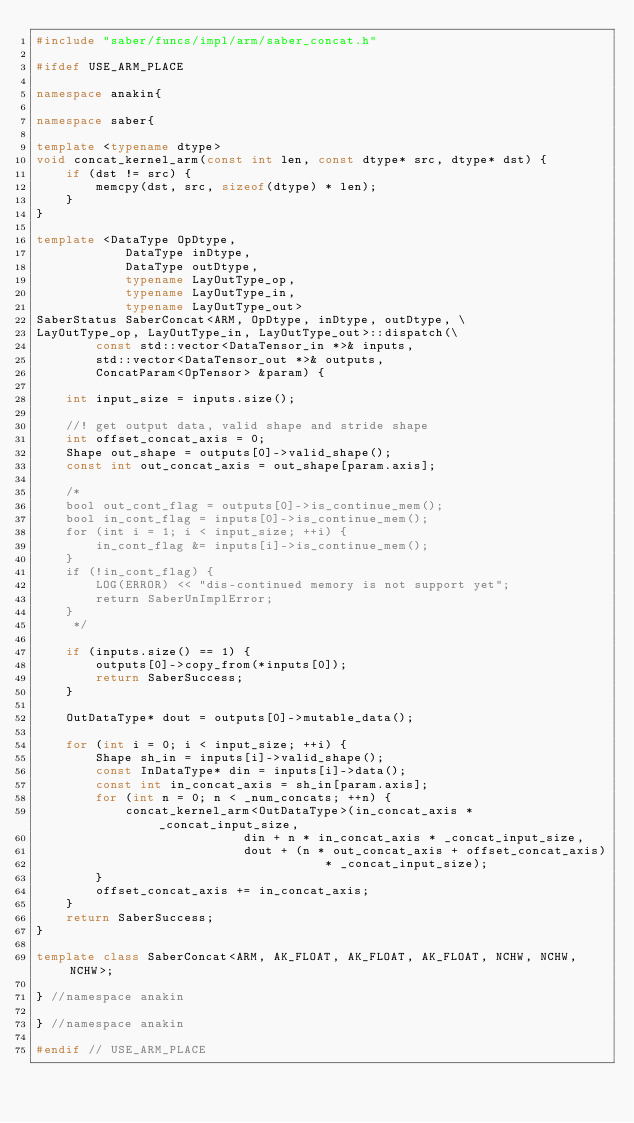Convert code to text. <code><loc_0><loc_0><loc_500><loc_500><_C++_>#include "saber/funcs/impl/arm/saber_concat.h"

#ifdef USE_ARM_PLACE

namespace anakin{

namespace saber{

template <typename dtype>
void concat_kernel_arm(const int len, const dtype* src, dtype* dst) {
    if (dst != src) {
        memcpy(dst, src, sizeof(dtype) * len);
    }
}

template <DataType OpDtype,
            DataType inDtype,
            DataType outDtype,
            typename LayOutType_op,
            typename LayOutType_in,
            typename LayOutType_out>
SaberStatus SaberConcat<ARM, OpDtype, inDtype, outDtype, \
LayOutType_op, LayOutType_in, LayOutType_out>::dispatch(\
        const std::vector<DataTensor_in *>& inputs,
        std::vector<DataTensor_out *>& outputs,
        ConcatParam<OpTensor> &param) {

    int input_size = inputs.size();

    //! get output data, valid shape and stride shape
    int offset_concat_axis = 0;
    Shape out_shape = outputs[0]->valid_shape();
    const int out_concat_axis = out_shape[param.axis];

    /*
    bool out_cont_flag = outputs[0]->is_continue_mem();
    bool in_cont_flag = inputs[0]->is_continue_mem();
    for (int i = 1; i < input_size; ++i) {
        in_cont_flag &= inputs[i]->is_continue_mem();
    }
    if (!in_cont_flag) {
        LOG(ERROR) << "dis-continued memory is not support yet";
        return SaberUnImplError;
    }
     */

    if (inputs.size() == 1) {
        outputs[0]->copy_from(*inputs[0]);
        return SaberSuccess;
    }

    OutDataType* dout = outputs[0]->mutable_data();

    for (int i = 0; i < input_size; ++i) {
        Shape sh_in = inputs[i]->valid_shape();
        const InDataType* din = inputs[i]->data();
        const int in_concat_axis = sh_in[param.axis];
        for (int n = 0; n < _num_concats; ++n) {
            concat_kernel_arm<OutDataType>(in_concat_axis * _concat_input_size,
                            din + n * in_concat_axis * _concat_input_size,
                            dout + (n * out_concat_axis + offset_concat_axis)
                                       * _concat_input_size);
        }
        offset_concat_axis += in_concat_axis;
    }
    return SaberSuccess;
}

template class SaberConcat<ARM, AK_FLOAT, AK_FLOAT, AK_FLOAT, NCHW, NCHW, NCHW>;

} //namespace anakin

} //namespace anakin

#endif // USE_ARM_PLACE
</code> 